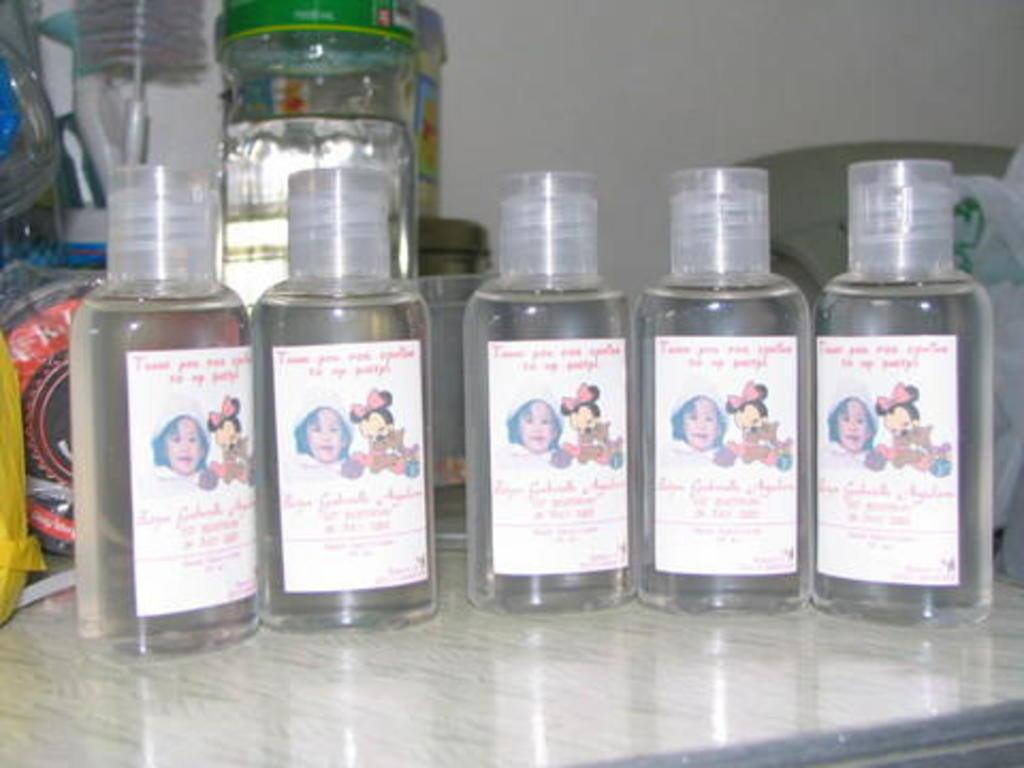What can be seen on the bottles in the image? There are stickers on the bottles in the image. What is located in the background of the image? There is a jar, plastic covers, and a wall in the background of the image. Where are the bottles placed? The bottles are placed on a glass floor. What type of hair can be seen on the bottles in the image? There is no hair present on the bottles in the image; they have stickers on them. 